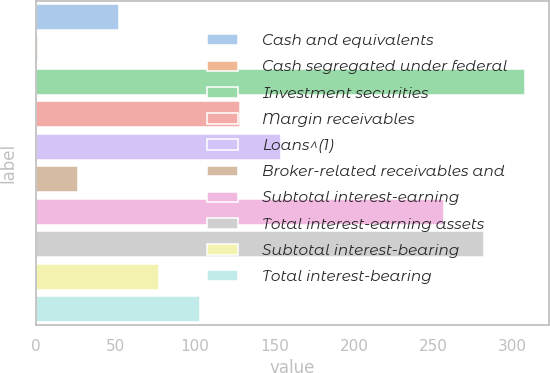<chart> <loc_0><loc_0><loc_500><loc_500><bar_chart><fcel>Cash and equivalents<fcel>Cash segregated under federal<fcel>Investment securities<fcel>Margin receivables<fcel>Loans^(1)<fcel>Broker-related receivables and<fcel>Subtotal interest-earning<fcel>Total interest-earning assets<fcel>Subtotal interest-bearing<fcel>Total interest-bearing<nl><fcel>52<fcel>1<fcel>307.5<fcel>128.5<fcel>154<fcel>26.5<fcel>256.5<fcel>282<fcel>77.5<fcel>103<nl></chart> 